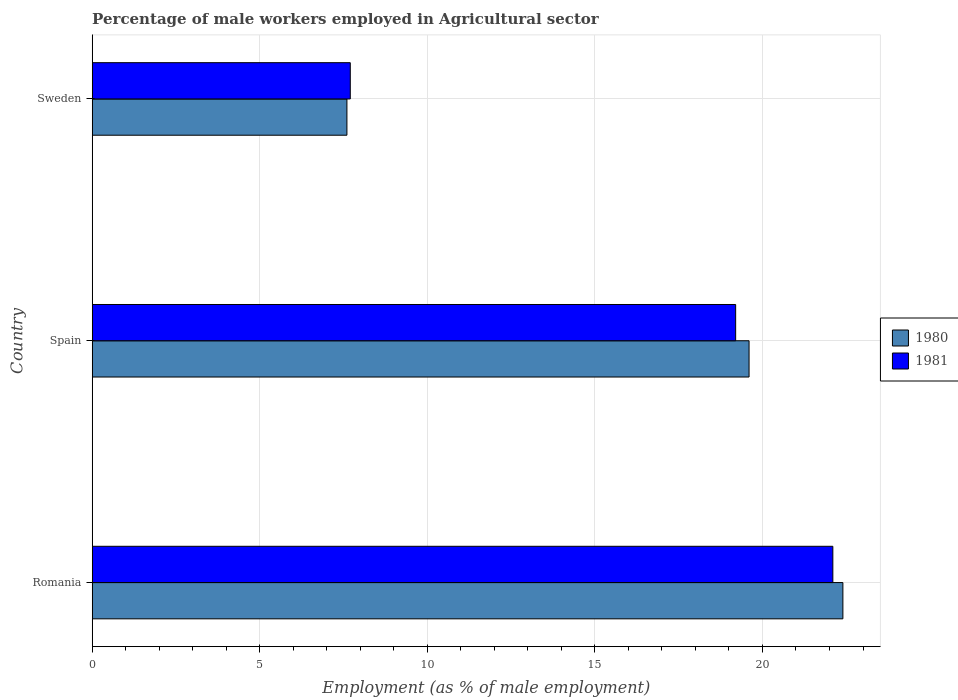What is the label of the 2nd group of bars from the top?
Offer a terse response. Spain. What is the percentage of male workers employed in Agricultural sector in 1980 in Romania?
Provide a succinct answer. 22.4. Across all countries, what is the maximum percentage of male workers employed in Agricultural sector in 1980?
Your answer should be compact. 22.4. Across all countries, what is the minimum percentage of male workers employed in Agricultural sector in 1980?
Provide a succinct answer. 7.6. In which country was the percentage of male workers employed in Agricultural sector in 1980 maximum?
Offer a terse response. Romania. In which country was the percentage of male workers employed in Agricultural sector in 1981 minimum?
Offer a terse response. Sweden. What is the total percentage of male workers employed in Agricultural sector in 1980 in the graph?
Your answer should be compact. 49.6. What is the difference between the percentage of male workers employed in Agricultural sector in 1981 in Romania and that in Sweden?
Provide a succinct answer. 14.4. What is the difference between the percentage of male workers employed in Agricultural sector in 1981 in Romania and the percentage of male workers employed in Agricultural sector in 1980 in Sweden?
Keep it short and to the point. 14.5. What is the average percentage of male workers employed in Agricultural sector in 1980 per country?
Make the answer very short. 16.53. What is the difference between the percentage of male workers employed in Agricultural sector in 1981 and percentage of male workers employed in Agricultural sector in 1980 in Sweden?
Your answer should be compact. 0.1. In how many countries, is the percentage of male workers employed in Agricultural sector in 1980 greater than 20 %?
Offer a very short reply. 1. What is the ratio of the percentage of male workers employed in Agricultural sector in 1981 in Romania to that in Sweden?
Provide a short and direct response. 2.87. Is the percentage of male workers employed in Agricultural sector in 1981 in Romania less than that in Sweden?
Keep it short and to the point. No. Is the difference between the percentage of male workers employed in Agricultural sector in 1981 in Spain and Sweden greater than the difference between the percentage of male workers employed in Agricultural sector in 1980 in Spain and Sweden?
Ensure brevity in your answer.  No. What is the difference between the highest and the second highest percentage of male workers employed in Agricultural sector in 1981?
Give a very brief answer. 2.9. What is the difference between the highest and the lowest percentage of male workers employed in Agricultural sector in 1981?
Provide a succinct answer. 14.4. In how many countries, is the percentage of male workers employed in Agricultural sector in 1980 greater than the average percentage of male workers employed in Agricultural sector in 1980 taken over all countries?
Offer a very short reply. 2. Is the sum of the percentage of male workers employed in Agricultural sector in 1981 in Romania and Sweden greater than the maximum percentage of male workers employed in Agricultural sector in 1980 across all countries?
Offer a very short reply. Yes. What does the 1st bar from the bottom in Romania represents?
Your answer should be very brief. 1980. How many countries are there in the graph?
Keep it short and to the point. 3. Does the graph contain grids?
Give a very brief answer. Yes. How many legend labels are there?
Ensure brevity in your answer.  2. What is the title of the graph?
Your answer should be very brief. Percentage of male workers employed in Agricultural sector. Does "1995" appear as one of the legend labels in the graph?
Your answer should be compact. No. What is the label or title of the X-axis?
Your answer should be very brief. Employment (as % of male employment). What is the label or title of the Y-axis?
Your answer should be very brief. Country. What is the Employment (as % of male employment) of 1980 in Romania?
Make the answer very short. 22.4. What is the Employment (as % of male employment) in 1981 in Romania?
Give a very brief answer. 22.1. What is the Employment (as % of male employment) of 1980 in Spain?
Your answer should be compact. 19.6. What is the Employment (as % of male employment) in 1981 in Spain?
Provide a short and direct response. 19.2. What is the Employment (as % of male employment) of 1980 in Sweden?
Keep it short and to the point. 7.6. What is the Employment (as % of male employment) of 1981 in Sweden?
Offer a terse response. 7.7. Across all countries, what is the maximum Employment (as % of male employment) in 1980?
Provide a short and direct response. 22.4. Across all countries, what is the maximum Employment (as % of male employment) of 1981?
Keep it short and to the point. 22.1. Across all countries, what is the minimum Employment (as % of male employment) of 1980?
Ensure brevity in your answer.  7.6. Across all countries, what is the minimum Employment (as % of male employment) of 1981?
Your response must be concise. 7.7. What is the total Employment (as % of male employment) in 1980 in the graph?
Your response must be concise. 49.6. What is the total Employment (as % of male employment) of 1981 in the graph?
Keep it short and to the point. 49. What is the difference between the Employment (as % of male employment) in 1980 in Romania and that in Spain?
Make the answer very short. 2.8. What is the difference between the Employment (as % of male employment) of 1981 in Romania and that in Spain?
Provide a short and direct response. 2.9. What is the difference between the Employment (as % of male employment) of 1980 in Spain and that in Sweden?
Ensure brevity in your answer.  12. What is the difference between the Employment (as % of male employment) of 1980 in Romania and the Employment (as % of male employment) of 1981 in Spain?
Provide a succinct answer. 3.2. What is the difference between the Employment (as % of male employment) of 1980 in Romania and the Employment (as % of male employment) of 1981 in Sweden?
Keep it short and to the point. 14.7. What is the difference between the Employment (as % of male employment) in 1980 in Spain and the Employment (as % of male employment) in 1981 in Sweden?
Your answer should be very brief. 11.9. What is the average Employment (as % of male employment) in 1980 per country?
Keep it short and to the point. 16.53. What is the average Employment (as % of male employment) in 1981 per country?
Make the answer very short. 16.33. What is the difference between the Employment (as % of male employment) of 1980 and Employment (as % of male employment) of 1981 in Romania?
Give a very brief answer. 0.3. What is the difference between the Employment (as % of male employment) in 1980 and Employment (as % of male employment) in 1981 in Sweden?
Your answer should be very brief. -0.1. What is the ratio of the Employment (as % of male employment) of 1981 in Romania to that in Spain?
Provide a short and direct response. 1.15. What is the ratio of the Employment (as % of male employment) in 1980 in Romania to that in Sweden?
Your answer should be compact. 2.95. What is the ratio of the Employment (as % of male employment) in 1981 in Romania to that in Sweden?
Offer a terse response. 2.87. What is the ratio of the Employment (as % of male employment) in 1980 in Spain to that in Sweden?
Give a very brief answer. 2.58. What is the ratio of the Employment (as % of male employment) in 1981 in Spain to that in Sweden?
Your answer should be very brief. 2.49. What is the difference between the highest and the second highest Employment (as % of male employment) of 1981?
Provide a succinct answer. 2.9. What is the difference between the highest and the lowest Employment (as % of male employment) of 1980?
Make the answer very short. 14.8. What is the difference between the highest and the lowest Employment (as % of male employment) in 1981?
Keep it short and to the point. 14.4. 